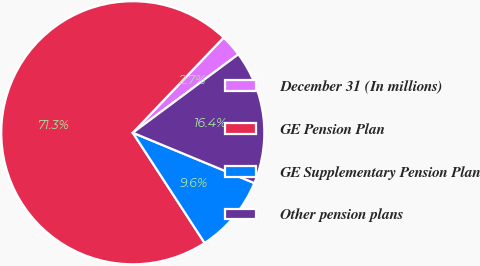Convert chart. <chart><loc_0><loc_0><loc_500><loc_500><pie_chart><fcel>December 31 (In millions)<fcel>GE Pension Plan<fcel>GE Supplementary Pension Plan<fcel>Other pension plans<nl><fcel>2.7%<fcel>71.31%<fcel>9.56%<fcel>16.42%<nl></chart> 